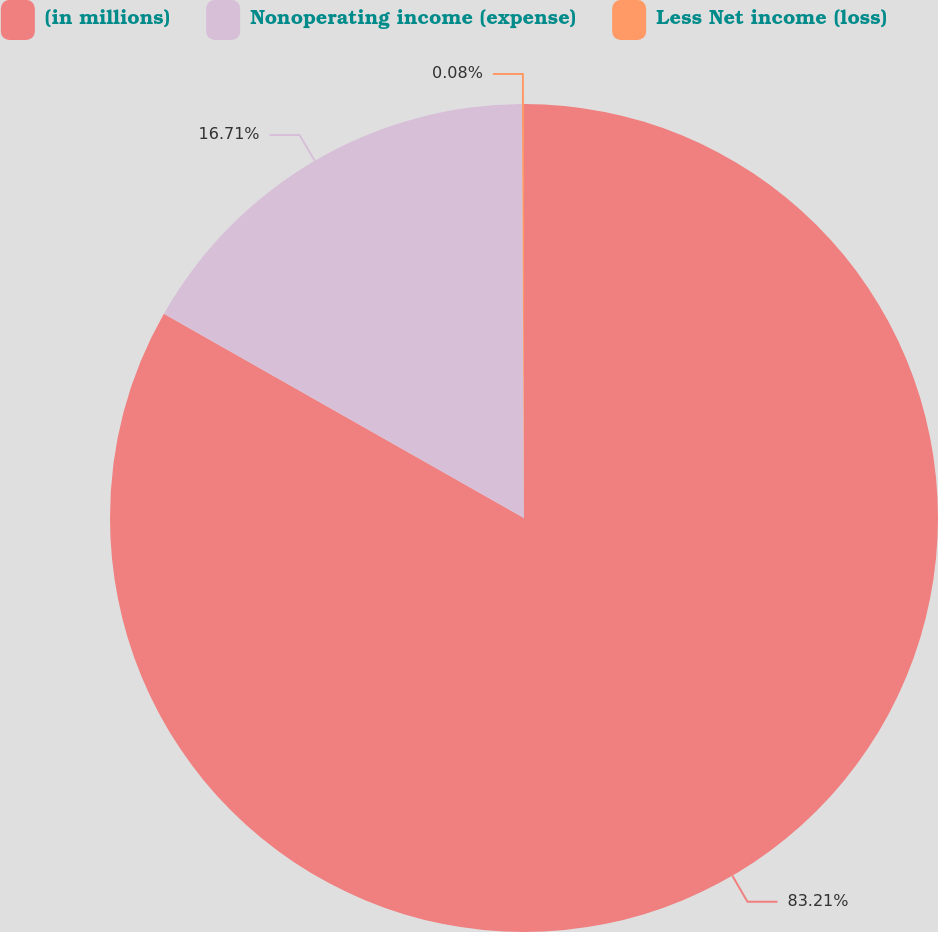Convert chart. <chart><loc_0><loc_0><loc_500><loc_500><pie_chart><fcel>(in millions)<fcel>Nonoperating income (expense)<fcel>Less Net income (loss)<nl><fcel>83.21%<fcel>16.71%<fcel>0.08%<nl></chart> 